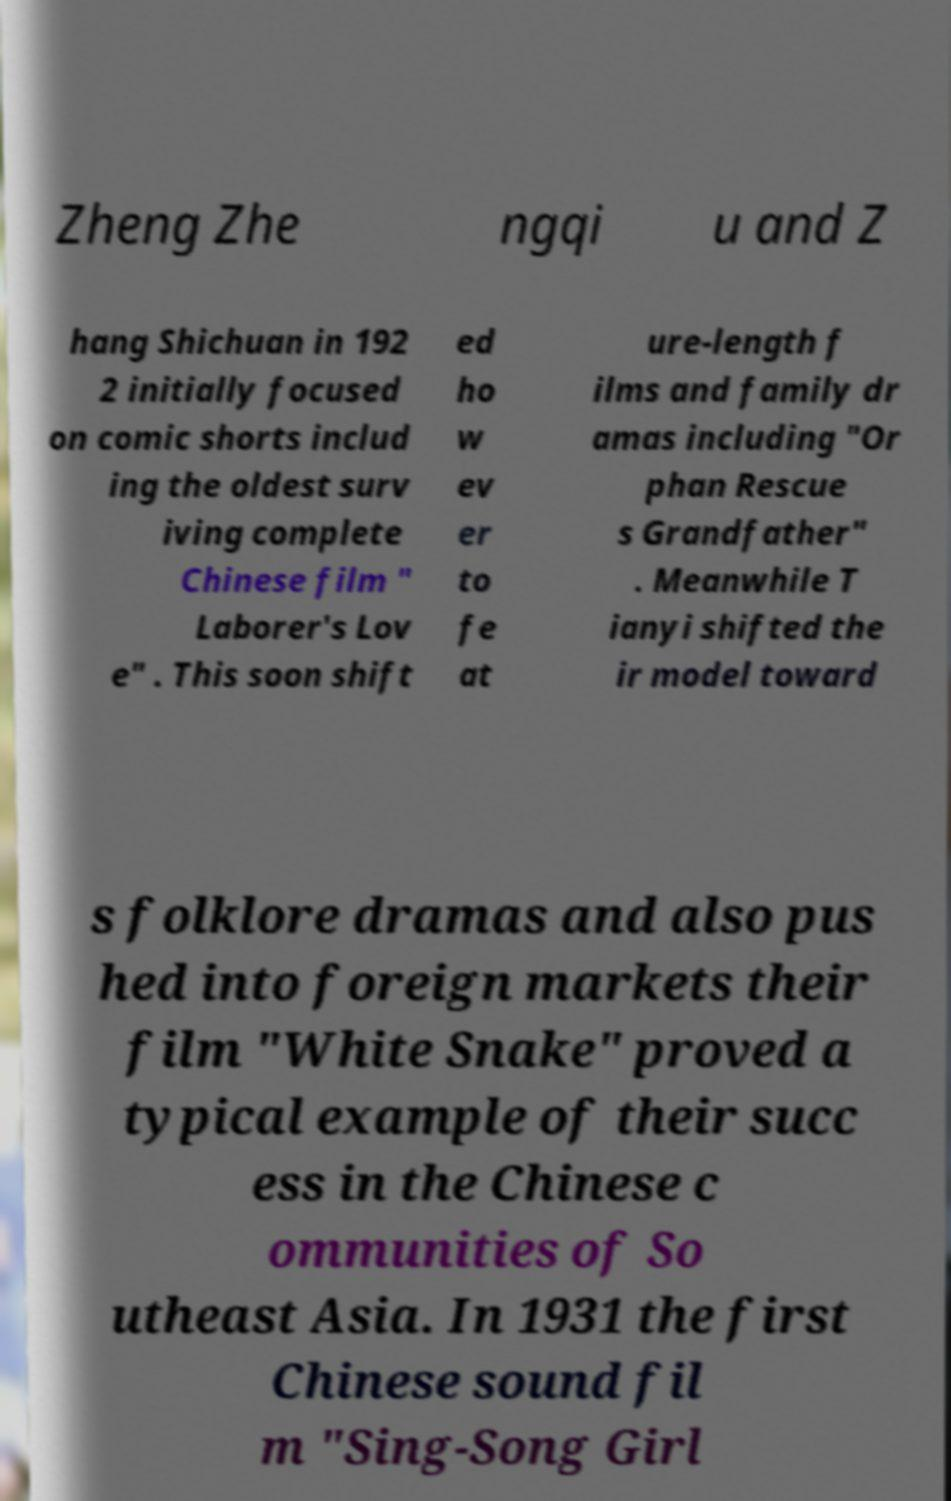Please read and relay the text visible in this image. What does it say? Zheng Zhe ngqi u and Z hang Shichuan in 192 2 initially focused on comic shorts includ ing the oldest surv iving complete Chinese film " Laborer's Lov e" . This soon shift ed ho w ev er to fe at ure-length f ilms and family dr amas including "Or phan Rescue s Grandfather" . Meanwhile T ianyi shifted the ir model toward s folklore dramas and also pus hed into foreign markets their film "White Snake" proved a typical example of their succ ess in the Chinese c ommunities of So utheast Asia. In 1931 the first Chinese sound fil m "Sing-Song Girl 